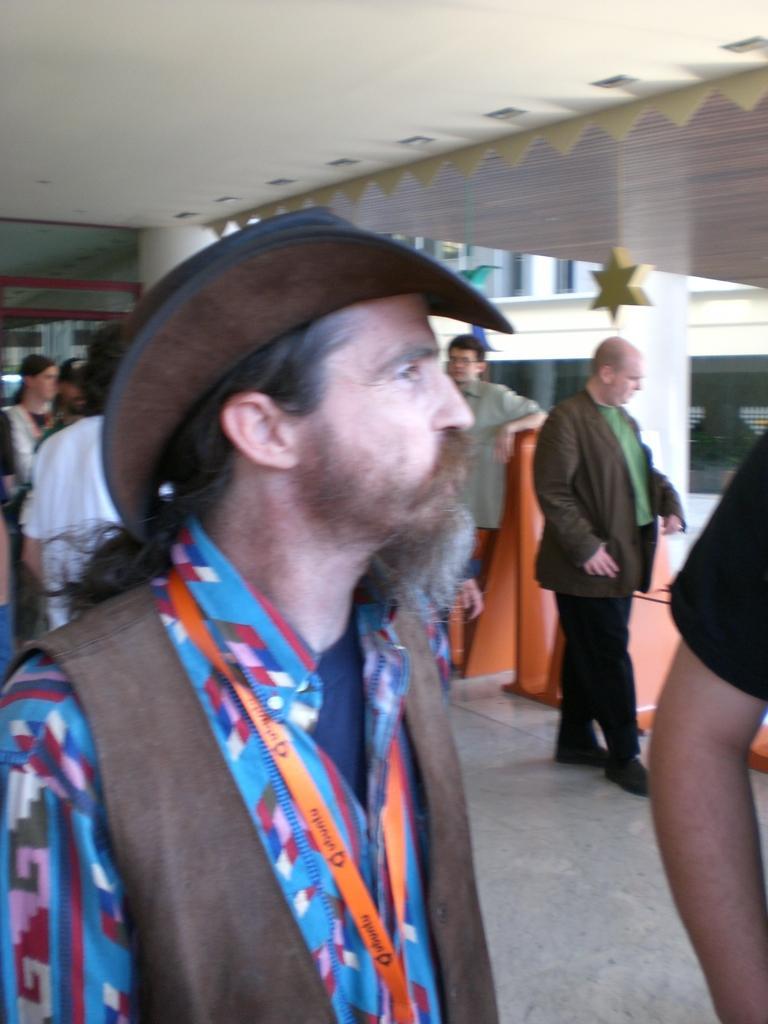Describe this image in one or two sentences. In this image there are persons standing and walking. In the background there is a building and there is an object which is red in colour. 